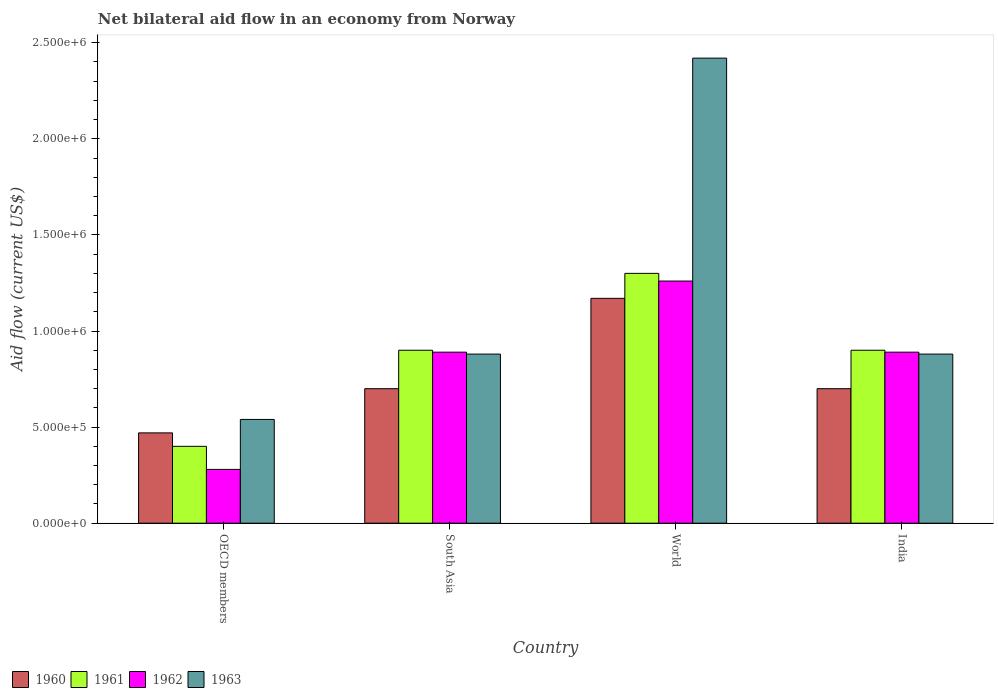How many groups of bars are there?
Offer a terse response. 4. Are the number of bars on each tick of the X-axis equal?
Your answer should be very brief. Yes. How many bars are there on the 4th tick from the left?
Your answer should be compact. 4. What is the label of the 1st group of bars from the left?
Ensure brevity in your answer.  OECD members. What is the net bilateral aid flow in 1962 in South Asia?
Provide a short and direct response. 8.90e+05. Across all countries, what is the maximum net bilateral aid flow in 1960?
Provide a succinct answer. 1.17e+06. Across all countries, what is the minimum net bilateral aid flow in 1960?
Offer a very short reply. 4.70e+05. In which country was the net bilateral aid flow in 1963 maximum?
Keep it short and to the point. World. In which country was the net bilateral aid flow in 1963 minimum?
Provide a succinct answer. OECD members. What is the total net bilateral aid flow in 1960 in the graph?
Keep it short and to the point. 3.04e+06. What is the difference between the net bilateral aid flow in 1962 in South Asia and that in World?
Provide a succinct answer. -3.70e+05. What is the difference between the net bilateral aid flow in 1962 in India and the net bilateral aid flow in 1960 in World?
Your answer should be compact. -2.80e+05. What is the average net bilateral aid flow in 1961 per country?
Provide a succinct answer. 8.75e+05. What is the difference between the net bilateral aid flow of/in 1960 and net bilateral aid flow of/in 1963 in South Asia?
Keep it short and to the point. -1.80e+05. In how many countries, is the net bilateral aid flow in 1962 greater than 1100000 US$?
Provide a short and direct response. 1. What is the ratio of the net bilateral aid flow in 1963 in OECD members to that in World?
Keep it short and to the point. 0.22. Is the net bilateral aid flow in 1962 in India less than that in South Asia?
Provide a short and direct response. No. Is the difference between the net bilateral aid flow in 1960 in India and OECD members greater than the difference between the net bilateral aid flow in 1963 in India and OECD members?
Your answer should be very brief. No. What is the difference between the highest and the second highest net bilateral aid flow in 1960?
Offer a very short reply. 4.70e+05. What is the difference between the highest and the lowest net bilateral aid flow in 1963?
Offer a terse response. 1.88e+06. In how many countries, is the net bilateral aid flow in 1961 greater than the average net bilateral aid flow in 1961 taken over all countries?
Your answer should be compact. 3. What does the 3rd bar from the right in World represents?
Your answer should be very brief. 1961. Is it the case that in every country, the sum of the net bilateral aid flow in 1963 and net bilateral aid flow in 1960 is greater than the net bilateral aid flow in 1962?
Offer a terse response. Yes. How many countries are there in the graph?
Provide a succinct answer. 4. Are the values on the major ticks of Y-axis written in scientific E-notation?
Your answer should be very brief. Yes. Does the graph contain any zero values?
Ensure brevity in your answer.  No. How many legend labels are there?
Your answer should be compact. 4. How are the legend labels stacked?
Ensure brevity in your answer.  Horizontal. What is the title of the graph?
Keep it short and to the point. Net bilateral aid flow in an economy from Norway. What is the Aid flow (current US$) in 1961 in OECD members?
Keep it short and to the point. 4.00e+05. What is the Aid flow (current US$) in 1962 in OECD members?
Offer a very short reply. 2.80e+05. What is the Aid flow (current US$) in 1963 in OECD members?
Offer a very short reply. 5.40e+05. What is the Aid flow (current US$) of 1962 in South Asia?
Your answer should be compact. 8.90e+05. What is the Aid flow (current US$) in 1963 in South Asia?
Give a very brief answer. 8.80e+05. What is the Aid flow (current US$) of 1960 in World?
Your response must be concise. 1.17e+06. What is the Aid flow (current US$) of 1961 in World?
Offer a very short reply. 1.30e+06. What is the Aid flow (current US$) in 1962 in World?
Provide a succinct answer. 1.26e+06. What is the Aid flow (current US$) of 1963 in World?
Your answer should be compact. 2.42e+06. What is the Aid flow (current US$) in 1962 in India?
Provide a succinct answer. 8.90e+05. What is the Aid flow (current US$) in 1963 in India?
Give a very brief answer. 8.80e+05. Across all countries, what is the maximum Aid flow (current US$) in 1960?
Your response must be concise. 1.17e+06. Across all countries, what is the maximum Aid flow (current US$) of 1961?
Offer a terse response. 1.30e+06. Across all countries, what is the maximum Aid flow (current US$) of 1962?
Provide a short and direct response. 1.26e+06. Across all countries, what is the maximum Aid flow (current US$) of 1963?
Your response must be concise. 2.42e+06. Across all countries, what is the minimum Aid flow (current US$) of 1960?
Offer a terse response. 4.70e+05. Across all countries, what is the minimum Aid flow (current US$) in 1961?
Your answer should be very brief. 4.00e+05. Across all countries, what is the minimum Aid flow (current US$) in 1963?
Keep it short and to the point. 5.40e+05. What is the total Aid flow (current US$) of 1960 in the graph?
Your response must be concise. 3.04e+06. What is the total Aid flow (current US$) of 1961 in the graph?
Provide a succinct answer. 3.50e+06. What is the total Aid flow (current US$) of 1962 in the graph?
Provide a succinct answer. 3.32e+06. What is the total Aid flow (current US$) in 1963 in the graph?
Keep it short and to the point. 4.72e+06. What is the difference between the Aid flow (current US$) of 1961 in OECD members and that in South Asia?
Provide a succinct answer. -5.00e+05. What is the difference between the Aid flow (current US$) in 1962 in OECD members and that in South Asia?
Offer a very short reply. -6.10e+05. What is the difference between the Aid flow (current US$) in 1960 in OECD members and that in World?
Offer a very short reply. -7.00e+05. What is the difference between the Aid flow (current US$) of 1961 in OECD members and that in World?
Your answer should be very brief. -9.00e+05. What is the difference between the Aid flow (current US$) in 1962 in OECD members and that in World?
Ensure brevity in your answer.  -9.80e+05. What is the difference between the Aid flow (current US$) of 1963 in OECD members and that in World?
Make the answer very short. -1.88e+06. What is the difference between the Aid flow (current US$) in 1961 in OECD members and that in India?
Offer a terse response. -5.00e+05. What is the difference between the Aid flow (current US$) in 1962 in OECD members and that in India?
Offer a very short reply. -6.10e+05. What is the difference between the Aid flow (current US$) of 1963 in OECD members and that in India?
Keep it short and to the point. -3.40e+05. What is the difference between the Aid flow (current US$) of 1960 in South Asia and that in World?
Make the answer very short. -4.70e+05. What is the difference between the Aid flow (current US$) of 1961 in South Asia and that in World?
Offer a very short reply. -4.00e+05. What is the difference between the Aid flow (current US$) in 1962 in South Asia and that in World?
Your response must be concise. -3.70e+05. What is the difference between the Aid flow (current US$) in 1963 in South Asia and that in World?
Offer a very short reply. -1.54e+06. What is the difference between the Aid flow (current US$) of 1960 in South Asia and that in India?
Offer a very short reply. 0. What is the difference between the Aid flow (current US$) of 1961 in South Asia and that in India?
Make the answer very short. 0. What is the difference between the Aid flow (current US$) in 1962 in South Asia and that in India?
Your answer should be very brief. 0. What is the difference between the Aid flow (current US$) of 1963 in South Asia and that in India?
Provide a short and direct response. 0. What is the difference between the Aid flow (current US$) of 1960 in World and that in India?
Your response must be concise. 4.70e+05. What is the difference between the Aid flow (current US$) of 1963 in World and that in India?
Provide a succinct answer. 1.54e+06. What is the difference between the Aid flow (current US$) of 1960 in OECD members and the Aid flow (current US$) of 1961 in South Asia?
Your response must be concise. -4.30e+05. What is the difference between the Aid flow (current US$) of 1960 in OECD members and the Aid flow (current US$) of 1962 in South Asia?
Your answer should be very brief. -4.20e+05. What is the difference between the Aid flow (current US$) of 1960 in OECD members and the Aid flow (current US$) of 1963 in South Asia?
Your answer should be very brief. -4.10e+05. What is the difference between the Aid flow (current US$) of 1961 in OECD members and the Aid flow (current US$) of 1962 in South Asia?
Give a very brief answer. -4.90e+05. What is the difference between the Aid flow (current US$) of 1961 in OECD members and the Aid flow (current US$) of 1963 in South Asia?
Provide a short and direct response. -4.80e+05. What is the difference between the Aid flow (current US$) in 1962 in OECD members and the Aid flow (current US$) in 1963 in South Asia?
Your answer should be compact. -6.00e+05. What is the difference between the Aid flow (current US$) in 1960 in OECD members and the Aid flow (current US$) in 1961 in World?
Make the answer very short. -8.30e+05. What is the difference between the Aid flow (current US$) in 1960 in OECD members and the Aid flow (current US$) in 1962 in World?
Your answer should be very brief. -7.90e+05. What is the difference between the Aid flow (current US$) of 1960 in OECD members and the Aid flow (current US$) of 1963 in World?
Your answer should be very brief. -1.95e+06. What is the difference between the Aid flow (current US$) of 1961 in OECD members and the Aid flow (current US$) of 1962 in World?
Make the answer very short. -8.60e+05. What is the difference between the Aid flow (current US$) in 1961 in OECD members and the Aid flow (current US$) in 1963 in World?
Provide a succinct answer. -2.02e+06. What is the difference between the Aid flow (current US$) in 1962 in OECD members and the Aid flow (current US$) in 1963 in World?
Provide a succinct answer. -2.14e+06. What is the difference between the Aid flow (current US$) of 1960 in OECD members and the Aid flow (current US$) of 1961 in India?
Provide a succinct answer. -4.30e+05. What is the difference between the Aid flow (current US$) of 1960 in OECD members and the Aid flow (current US$) of 1962 in India?
Your answer should be compact. -4.20e+05. What is the difference between the Aid flow (current US$) of 1960 in OECD members and the Aid flow (current US$) of 1963 in India?
Offer a very short reply. -4.10e+05. What is the difference between the Aid flow (current US$) in 1961 in OECD members and the Aid flow (current US$) in 1962 in India?
Make the answer very short. -4.90e+05. What is the difference between the Aid flow (current US$) in 1961 in OECD members and the Aid flow (current US$) in 1963 in India?
Offer a very short reply. -4.80e+05. What is the difference between the Aid flow (current US$) of 1962 in OECD members and the Aid flow (current US$) of 1963 in India?
Your answer should be compact. -6.00e+05. What is the difference between the Aid flow (current US$) of 1960 in South Asia and the Aid flow (current US$) of 1961 in World?
Offer a very short reply. -6.00e+05. What is the difference between the Aid flow (current US$) of 1960 in South Asia and the Aid flow (current US$) of 1962 in World?
Keep it short and to the point. -5.60e+05. What is the difference between the Aid flow (current US$) in 1960 in South Asia and the Aid flow (current US$) in 1963 in World?
Make the answer very short. -1.72e+06. What is the difference between the Aid flow (current US$) of 1961 in South Asia and the Aid flow (current US$) of 1962 in World?
Provide a short and direct response. -3.60e+05. What is the difference between the Aid flow (current US$) of 1961 in South Asia and the Aid flow (current US$) of 1963 in World?
Your response must be concise. -1.52e+06. What is the difference between the Aid flow (current US$) of 1962 in South Asia and the Aid flow (current US$) of 1963 in World?
Make the answer very short. -1.53e+06. What is the difference between the Aid flow (current US$) in 1960 in South Asia and the Aid flow (current US$) in 1962 in India?
Offer a very short reply. -1.90e+05. What is the difference between the Aid flow (current US$) of 1960 in World and the Aid flow (current US$) of 1961 in India?
Provide a short and direct response. 2.70e+05. What is the difference between the Aid flow (current US$) in 1960 in World and the Aid flow (current US$) in 1963 in India?
Make the answer very short. 2.90e+05. What is the difference between the Aid flow (current US$) in 1961 in World and the Aid flow (current US$) in 1962 in India?
Give a very brief answer. 4.10e+05. What is the difference between the Aid flow (current US$) of 1961 in World and the Aid flow (current US$) of 1963 in India?
Offer a terse response. 4.20e+05. What is the average Aid flow (current US$) of 1960 per country?
Ensure brevity in your answer.  7.60e+05. What is the average Aid flow (current US$) of 1961 per country?
Your answer should be very brief. 8.75e+05. What is the average Aid flow (current US$) in 1962 per country?
Provide a short and direct response. 8.30e+05. What is the average Aid flow (current US$) of 1963 per country?
Give a very brief answer. 1.18e+06. What is the difference between the Aid flow (current US$) of 1960 and Aid flow (current US$) of 1962 in OECD members?
Provide a succinct answer. 1.90e+05. What is the difference between the Aid flow (current US$) in 1960 and Aid flow (current US$) in 1963 in OECD members?
Keep it short and to the point. -7.00e+04. What is the difference between the Aid flow (current US$) in 1962 and Aid flow (current US$) in 1963 in OECD members?
Ensure brevity in your answer.  -2.60e+05. What is the difference between the Aid flow (current US$) in 1960 and Aid flow (current US$) in 1962 in South Asia?
Your answer should be compact. -1.90e+05. What is the difference between the Aid flow (current US$) of 1960 and Aid flow (current US$) of 1963 in South Asia?
Your response must be concise. -1.80e+05. What is the difference between the Aid flow (current US$) in 1961 and Aid flow (current US$) in 1962 in South Asia?
Offer a terse response. 10000. What is the difference between the Aid flow (current US$) in 1961 and Aid flow (current US$) in 1963 in South Asia?
Your response must be concise. 2.00e+04. What is the difference between the Aid flow (current US$) in 1962 and Aid flow (current US$) in 1963 in South Asia?
Your response must be concise. 10000. What is the difference between the Aid flow (current US$) of 1960 and Aid flow (current US$) of 1961 in World?
Ensure brevity in your answer.  -1.30e+05. What is the difference between the Aid flow (current US$) in 1960 and Aid flow (current US$) in 1962 in World?
Your answer should be very brief. -9.00e+04. What is the difference between the Aid flow (current US$) in 1960 and Aid flow (current US$) in 1963 in World?
Give a very brief answer. -1.25e+06. What is the difference between the Aid flow (current US$) of 1961 and Aid flow (current US$) of 1962 in World?
Keep it short and to the point. 4.00e+04. What is the difference between the Aid flow (current US$) in 1961 and Aid flow (current US$) in 1963 in World?
Offer a terse response. -1.12e+06. What is the difference between the Aid flow (current US$) in 1962 and Aid flow (current US$) in 1963 in World?
Make the answer very short. -1.16e+06. What is the difference between the Aid flow (current US$) of 1960 and Aid flow (current US$) of 1961 in India?
Provide a succinct answer. -2.00e+05. What is the difference between the Aid flow (current US$) of 1962 and Aid flow (current US$) of 1963 in India?
Keep it short and to the point. 10000. What is the ratio of the Aid flow (current US$) of 1960 in OECD members to that in South Asia?
Give a very brief answer. 0.67. What is the ratio of the Aid flow (current US$) in 1961 in OECD members to that in South Asia?
Keep it short and to the point. 0.44. What is the ratio of the Aid flow (current US$) in 1962 in OECD members to that in South Asia?
Give a very brief answer. 0.31. What is the ratio of the Aid flow (current US$) of 1963 in OECD members to that in South Asia?
Your answer should be compact. 0.61. What is the ratio of the Aid flow (current US$) of 1960 in OECD members to that in World?
Provide a short and direct response. 0.4. What is the ratio of the Aid flow (current US$) in 1961 in OECD members to that in World?
Offer a very short reply. 0.31. What is the ratio of the Aid flow (current US$) in 1962 in OECD members to that in World?
Give a very brief answer. 0.22. What is the ratio of the Aid flow (current US$) of 1963 in OECD members to that in World?
Your answer should be very brief. 0.22. What is the ratio of the Aid flow (current US$) of 1960 in OECD members to that in India?
Provide a succinct answer. 0.67. What is the ratio of the Aid flow (current US$) of 1961 in OECD members to that in India?
Offer a very short reply. 0.44. What is the ratio of the Aid flow (current US$) of 1962 in OECD members to that in India?
Your answer should be very brief. 0.31. What is the ratio of the Aid flow (current US$) of 1963 in OECD members to that in India?
Your answer should be compact. 0.61. What is the ratio of the Aid flow (current US$) in 1960 in South Asia to that in World?
Offer a very short reply. 0.6. What is the ratio of the Aid flow (current US$) in 1961 in South Asia to that in World?
Make the answer very short. 0.69. What is the ratio of the Aid flow (current US$) in 1962 in South Asia to that in World?
Keep it short and to the point. 0.71. What is the ratio of the Aid flow (current US$) of 1963 in South Asia to that in World?
Keep it short and to the point. 0.36. What is the ratio of the Aid flow (current US$) of 1960 in South Asia to that in India?
Ensure brevity in your answer.  1. What is the ratio of the Aid flow (current US$) of 1963 in South Asia to that in India?
Provide a short and direct response. 1. What is the ratio of the Aid flow (current US$) in 1960 in World to that in India?
Keep it short and to the point. 1.67. What is the ratio of the Aid flow (current US$) in 1961 in World to that in India?
Offer a terse response. 1.44. What is the ratio of the Aid flow (current US$) in 1962 in World to that in India?
Offer a very short reply. 1.42. What is the ratio of the Aid flow (current US$) of 1963 in World to that in India?
Your answer should be very brief. 2.75. What is the difference between the highest and the second highest Aid flow (current US$) in 1960?
Provide a short and direct response. 4.70e+05. What is the difference between the highest and the second highest Aid flow (current US$) in 1961?
Provide a succinct answer. 4.00e+05. What is the difference between the highest and the second highest Aid flow (current US$) of 1963?
Give a very brief answer. 1.54e+06. What is the difference between the highest and the lowest Aid flow (current US$) in 1962?
Provide a succinct answer. 9.80e+05. What is the difference between the highest and the lowest Aid flow (current US$) of 1963?
Your answer should be compact. 1.88e+06. 